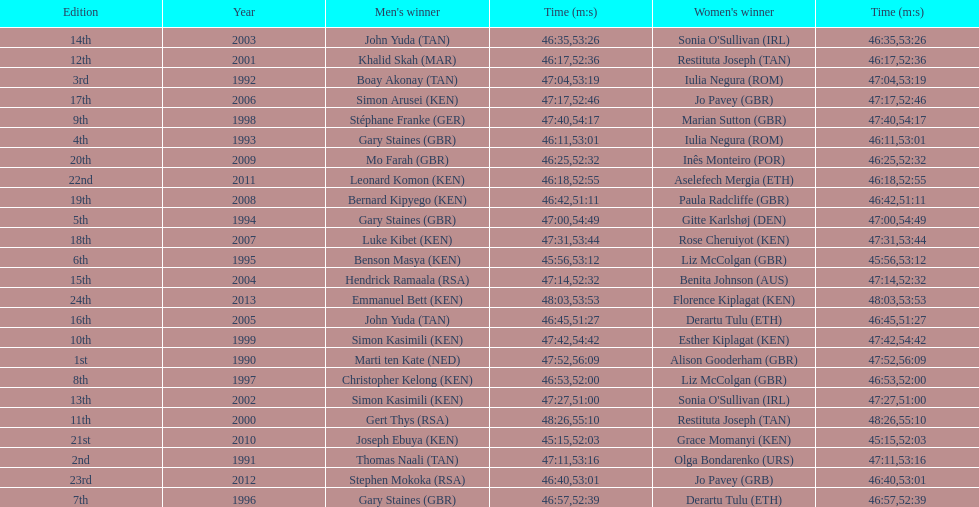What is the number of times, between 1990 and 2013, for britain not to win the men's or women's bupa great south run? 13. 